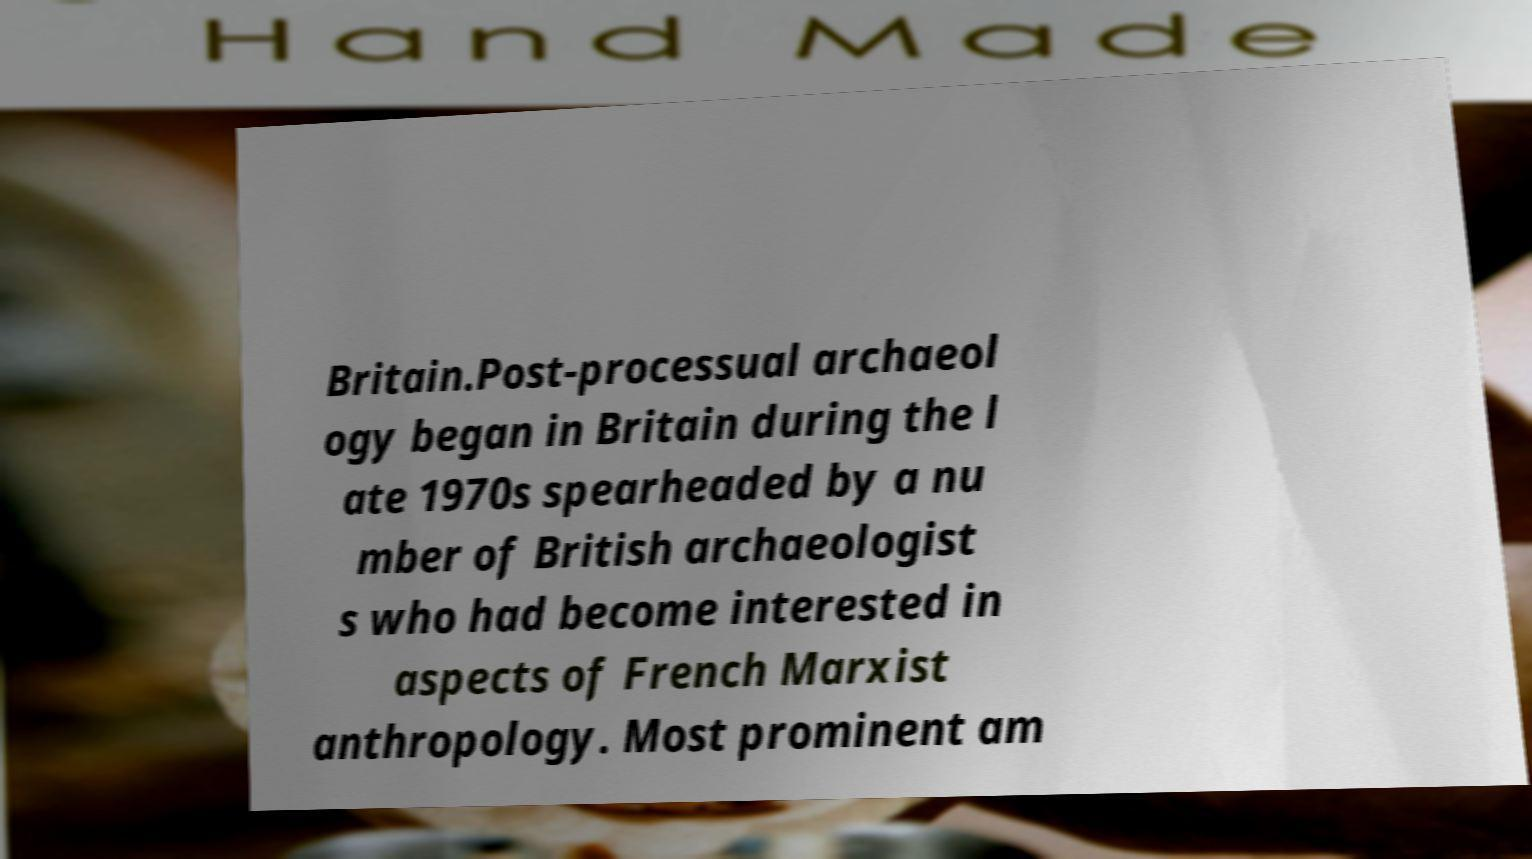Can you accurately transcribe the text from the provided image for me? Britain.Post-processual archaeol ogy began in Britain during the l ate 1970s spearheaded by a nu mber of British archaeologist s who had become interested in aspects of French Marxist anthropology. Most prominent am 